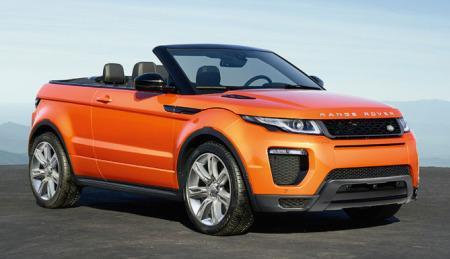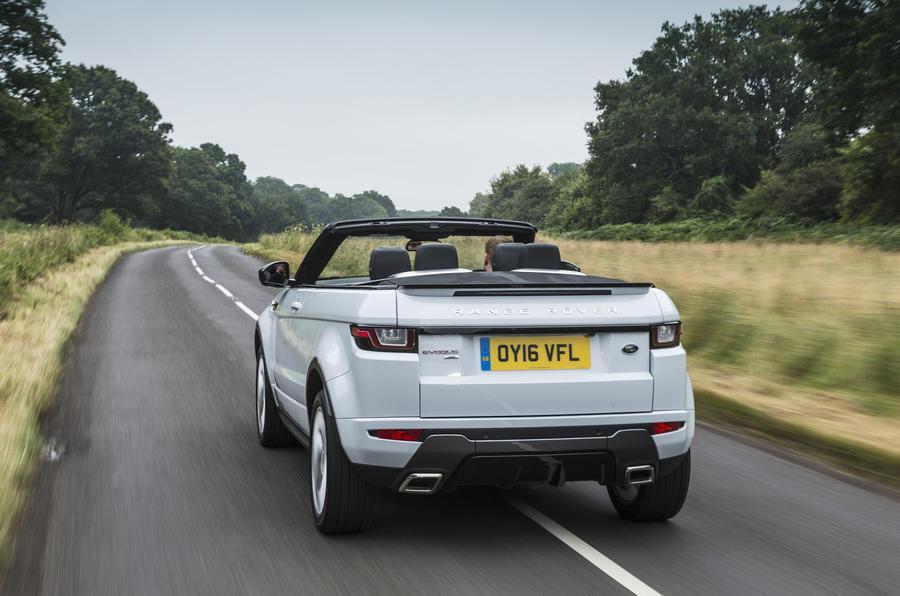The first image is the image on the left, the second image is the image on the right. Analyze the images presented: Is the assertion "All cars are topless convertibles, and one car is bright orange while the other is white." valid? Answer yes or no. Yes. The first image is the image on the left, the second image is the image on the right. Analyze the images presented: Is the assertion "The car in one of the images is driving near a snowy location." valid? Answer yes or no. No. 